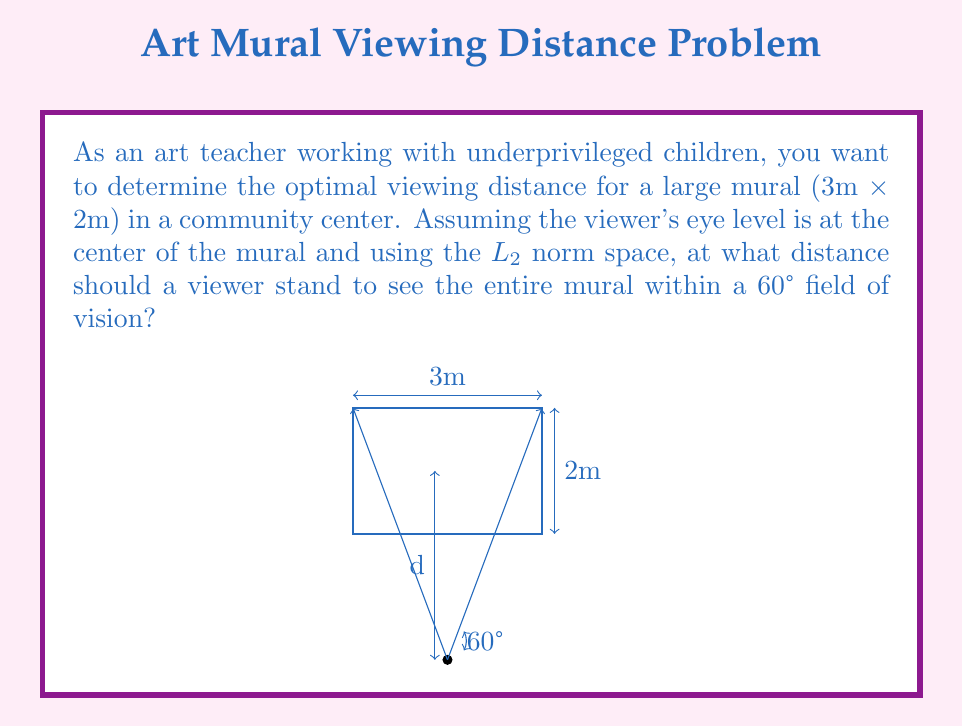Show me your answer to this math problem. Let's approach this step-by-step:

1) In the $L_2$ norm space, we're dealing with Euclidean distance. The viewer's position forms a right triangle with half of the mural's width and the viewing distance.

2) Let the viewing distance be $d$. Half of the mural's width is 1.5m.

3) The tangent of half the viewing angle (30°) is the ratio of half the mural's width to the viewing distance:

   $$\tan(30°) = \frac{1.5}{d}$$

4) We know that $\tan(30°) = \frac{1}{\sqrt{3}}$, so we can set up the equation:

   $$\frac{1}{\sqrt{3}} = \frac{1.5}{d}$$

5) Cross-multiply:

   $$d = 1.5\sqrt{3}$$

6) Calculate the value:

   $$d \approx 2.598 \text{ meters}$$

This distance ensures that the entire width of the mural fits within the 60° field of vision. It's worth noting that the height of the mural (2m) will also fit within this field of vision at this distance.
Answer: $1.5\sqrt{3} \approx 2.598 \text{ meters}$ 